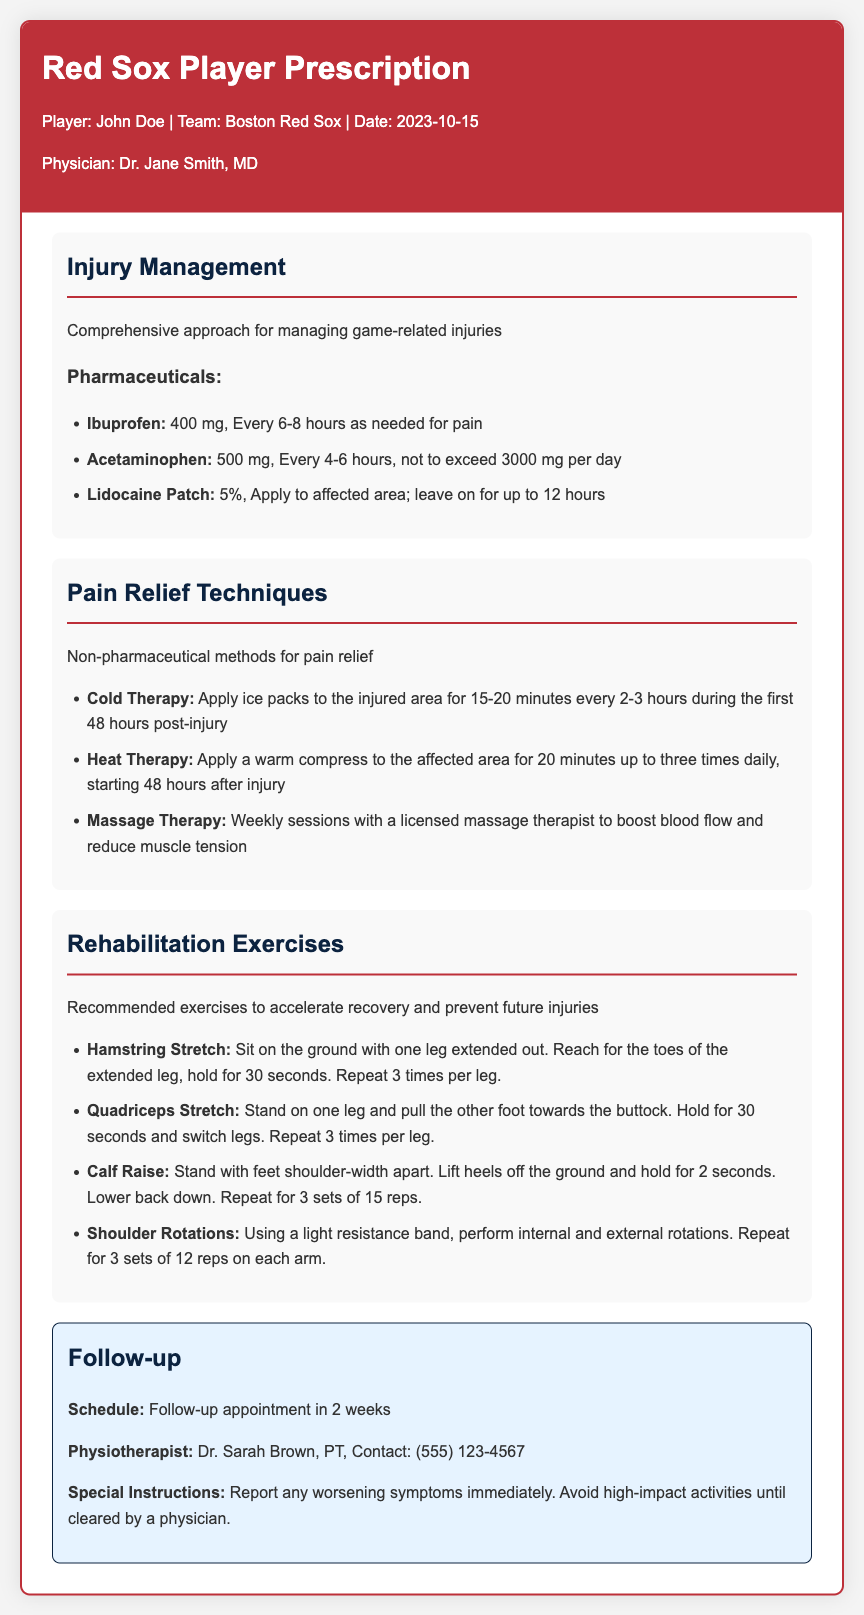What is the player's name? The player's name is mentioned in the header of the document as John Doe.
Answer: John Doe What is the date of the prescription? The date of the prescription is listed near the player's name in the header.
Answer: 2023-10-15 Who is the prescribing physician? The physician's name is provided in the header of the document, indicating who prescribed the treatment.
Answer: Dr. Jane Smith, MD How often should Ibuprofen be taken? The dosage instruction for Ibuprofen specifies how frequently it can be taken as needed for pain relief.
Answer: Every 6-8 hours What should be applied during the first 48 hours post-injury? The document provides guidelines for pain relief techniques, particularly for the initial post-injury period.
Answer: Ice packs How long should the Hamstring Stretch be held? The rehabilitation exercise section details the duration for holding the Hamstring Stretch.
Answer: 30 seconds What type of therapy is recommended weekly? The pain relief techniques section suggests methods that include therapy types that can aid in recovery.
Answer: Massage Therapy What is the follow-up schedule? The follow-up information notes the timeframe for the next appointment.
Answer: In 2 weeks What is the maximum daily dosage of Acetaminophen? The prescription outlines the limitations for taking Acetaminophen throughout the day.
Answer: 3000 mg per day 